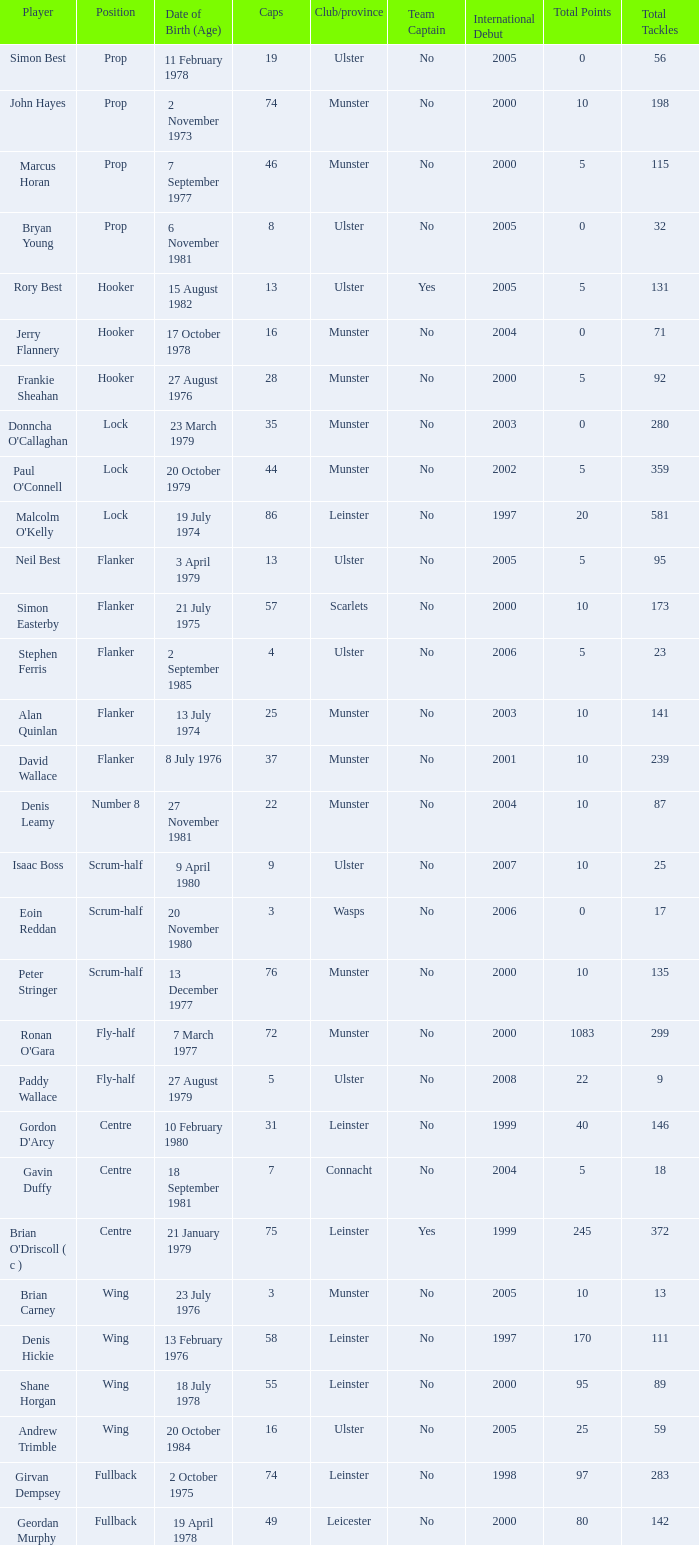What is the club or province of Girvan Dempsey, who has 74 caps? Leinster. 